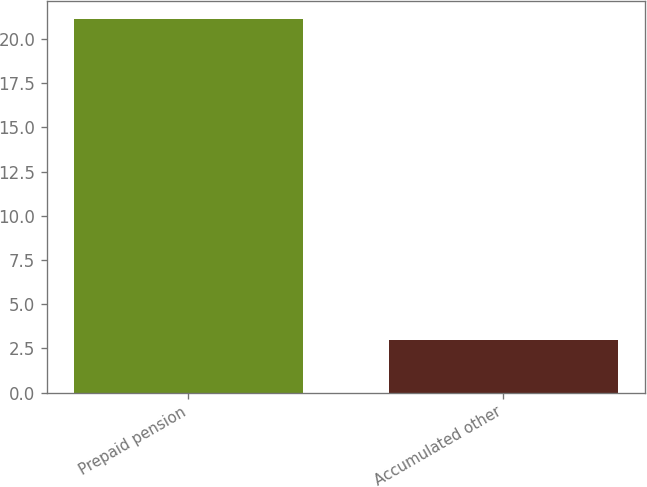Convert chart. <chart><loc_0><loc_0><loc_500><loc_500><bar_chart><fcel>Prepaid pension<fcel>Accumulated other<nl><fcel>21.1<fcel>3<nl></chart> 